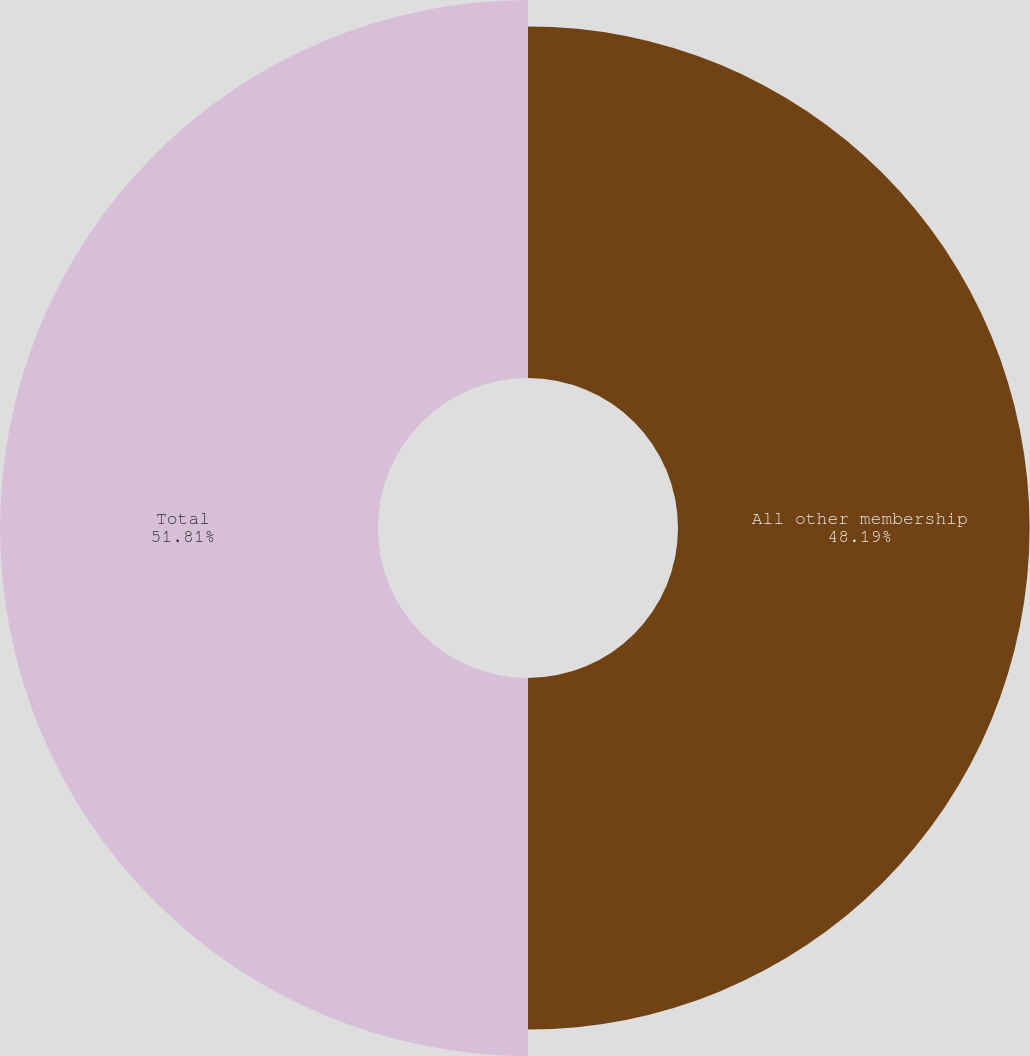<chart> <loc_0><loc_0><loc_500><loc_500><pie_chart><fcel>All other membership<fcel>Total<nl><fcel>48.19%<fcel>51.81%<nl></chart> 